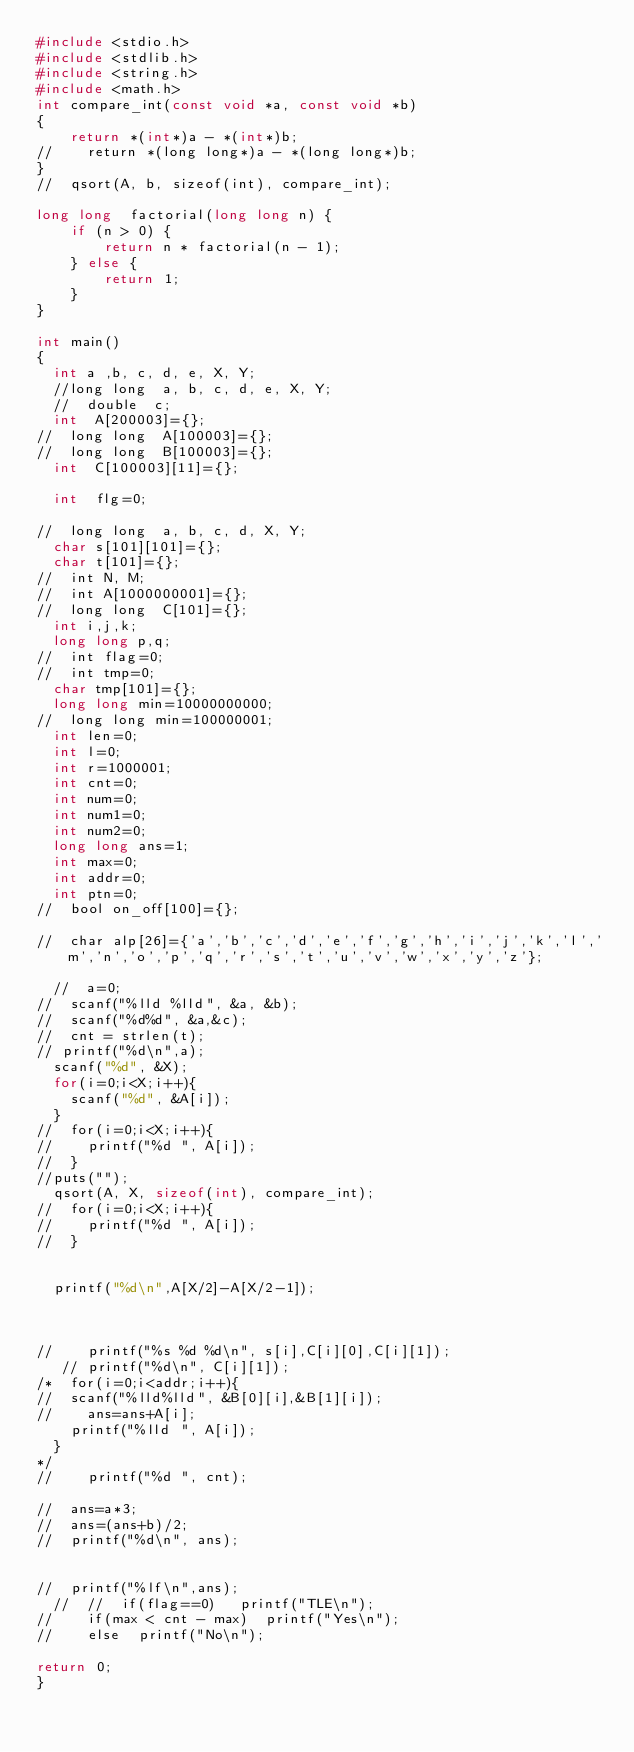Convert code to text. <code><loc_0><loc_0><loc_500><loc_500><_C_>#include <stdio.h>
#include <stdlib.h>
#include <string.h>
#include <math.h>
int compare_int(const void *a, const void *b)
{
    return *(int*)a - *(int*)b;
//    return *(long long*)a - *(long long*)b;
}
//  qsort(A, b, sizeof(int), compare_int);

long long  factorial(long long n) {
    if (n > 0) {
        return n * factorial(n - 1);
    } else {
        return 1;
    }
}

int main()
{
  int a ,b, c, d, e, X, Y;
  //long long  a, b, c, d, e, X, Y;
  //  double  c;
  int  A[200003]={};
//  long long  A[100003]={};
//  long long  B[100003]={};
  int  C[100003][11]={};

  int  flg=0;

//  long long  a, b, c, d, X, Y;
  char s[101][101]={};
  char t[101]={};
//  int N, M;
//  int A[1000000001]={};
//  long long  C[101]={};
  int i,j,k;
  long long p,q;
//  int flag=0;
//  int tmp=0;
  char tmp[101]={};
  long long min=10000000000;
//  long long min=100000001;
  int len=0;
  int l=0;
  int r=1000001;
  int cnt=0;
  int num=0;
  int num1=0;
  int num2=0;
  long long ans=1;
  int max=0;
  int addr=0;
  int ptn=0;
//  bool on_off[100]={};
  
//  char alp[26]={'a','b','c','d','e','f','g','h','i','j','k','l','m','n','o','p','q','r','s','t','u','v','w','x','y','z'};

  //  a=0;
//  scanf("%lld %lld", &a, &b);
//  scanf("%d%d", &a,&c);
//  cnt = strlen(t);
// printf("%d\n",a);
  scanf("%d", &X);
  for(i=0;i<X;i++){
    scanf("%d", &A[i]);
  }
//  for(i=0;i<X;i++){
//    printf("%d ", A[i]);
//  }
//puts("");
  qsort(A, X, sizeof(int), compare_int);
//  for(i=0;i<X;i++){
//    printf("%d ", A[i]);
//  }
  

  printf("%d\n",A[X/2]-A[X/2-1]);
  

    
//    printf("%s %d %d\n", s[i],C[i][0],C[i][1]);
   // printf("%d\n", C[i][1]);
/*  for(i=0;i<addr;i++){
//  scanf("%lld%lld", &B[0][i],&B[1][i]);
//    ans=ans+A[i];
    printf("%lld ", A[i]);
  }
*/
//    printf("%d ", cnt);
   
//  ans=a*3;
//  ans=(ans+b)/2;
//  printf("%d\n", ans);

  
//  printf("%lf\n",ans);
  //  //  if(flag==0)   printf("TLE\n");
//    if(max < cnt - max)  printf("Yes\n");
//    else  printf("No\n");
  
return 0;
}
</code> 